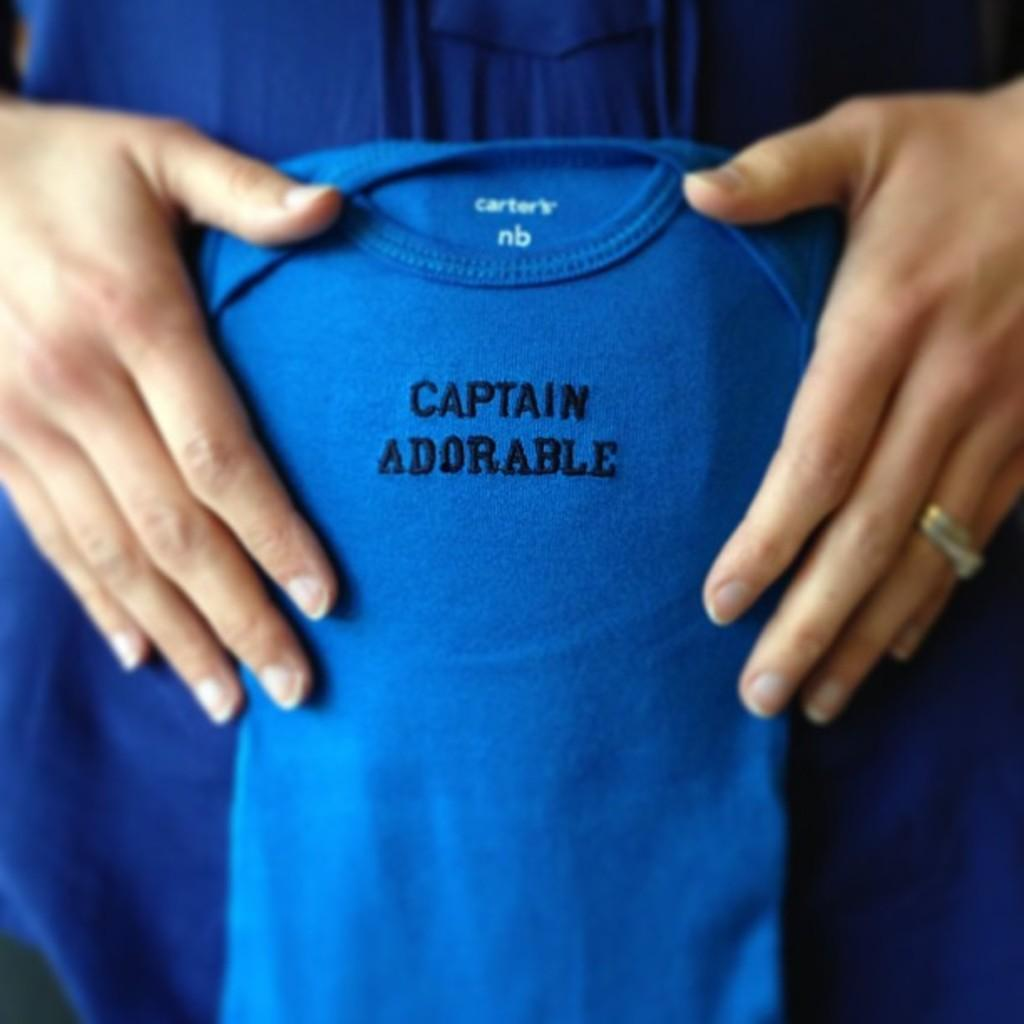Who is present in the image? There is a woman in the image. What is the woman holding in the image? The woman is holding a blue T-shirt. What can be seen on the T-shirt? There is text on the T-shirt. What is the woman wearing in the image? The woman is wearing a blue dress. What type of stove is visible in the image? There is no stove present in the image. What authority figure can be seen in the image? There is no authority figure present in the image. 